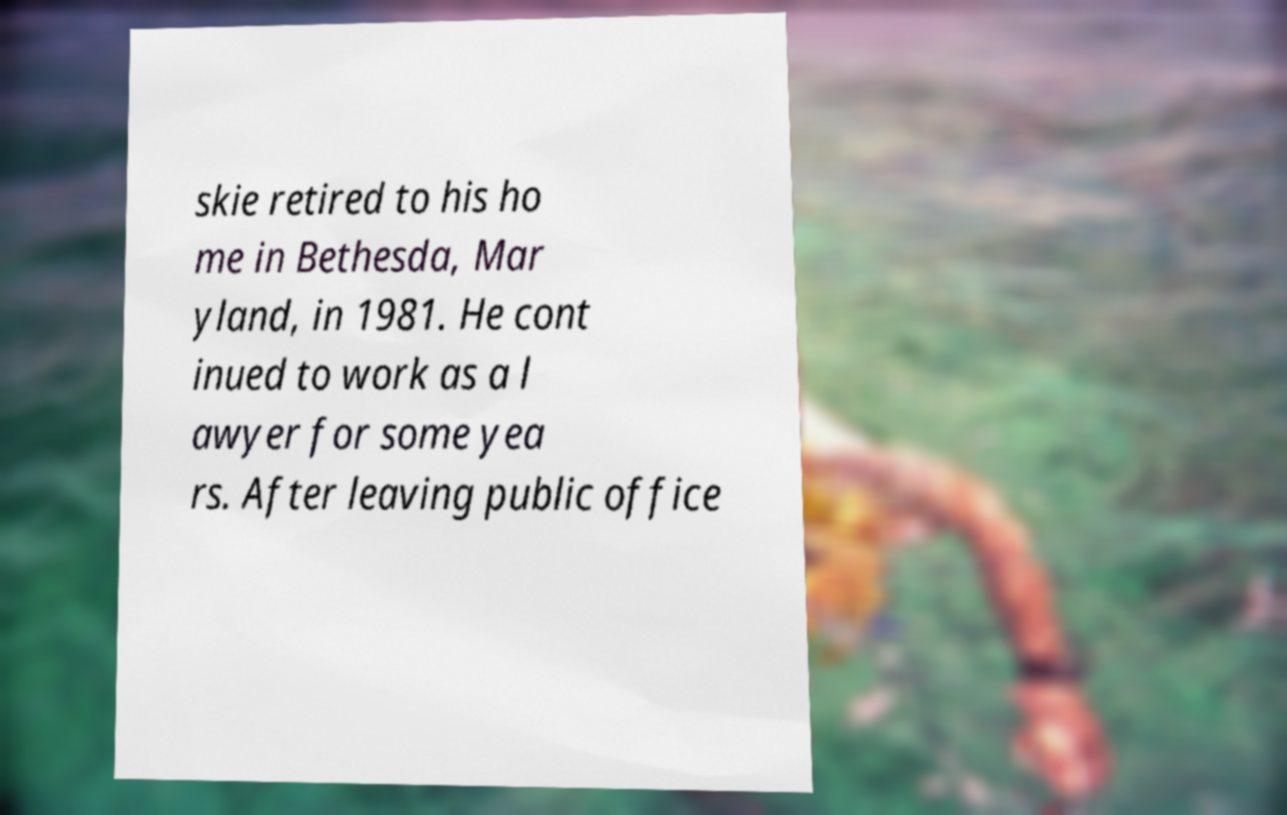Please read and relay the text visible in this image. What does it say? skie retired to his ho me in Bethesda, Mar yland, in 1981. He cont inued to work as a l awyer for some yea rs. After leaving public office 